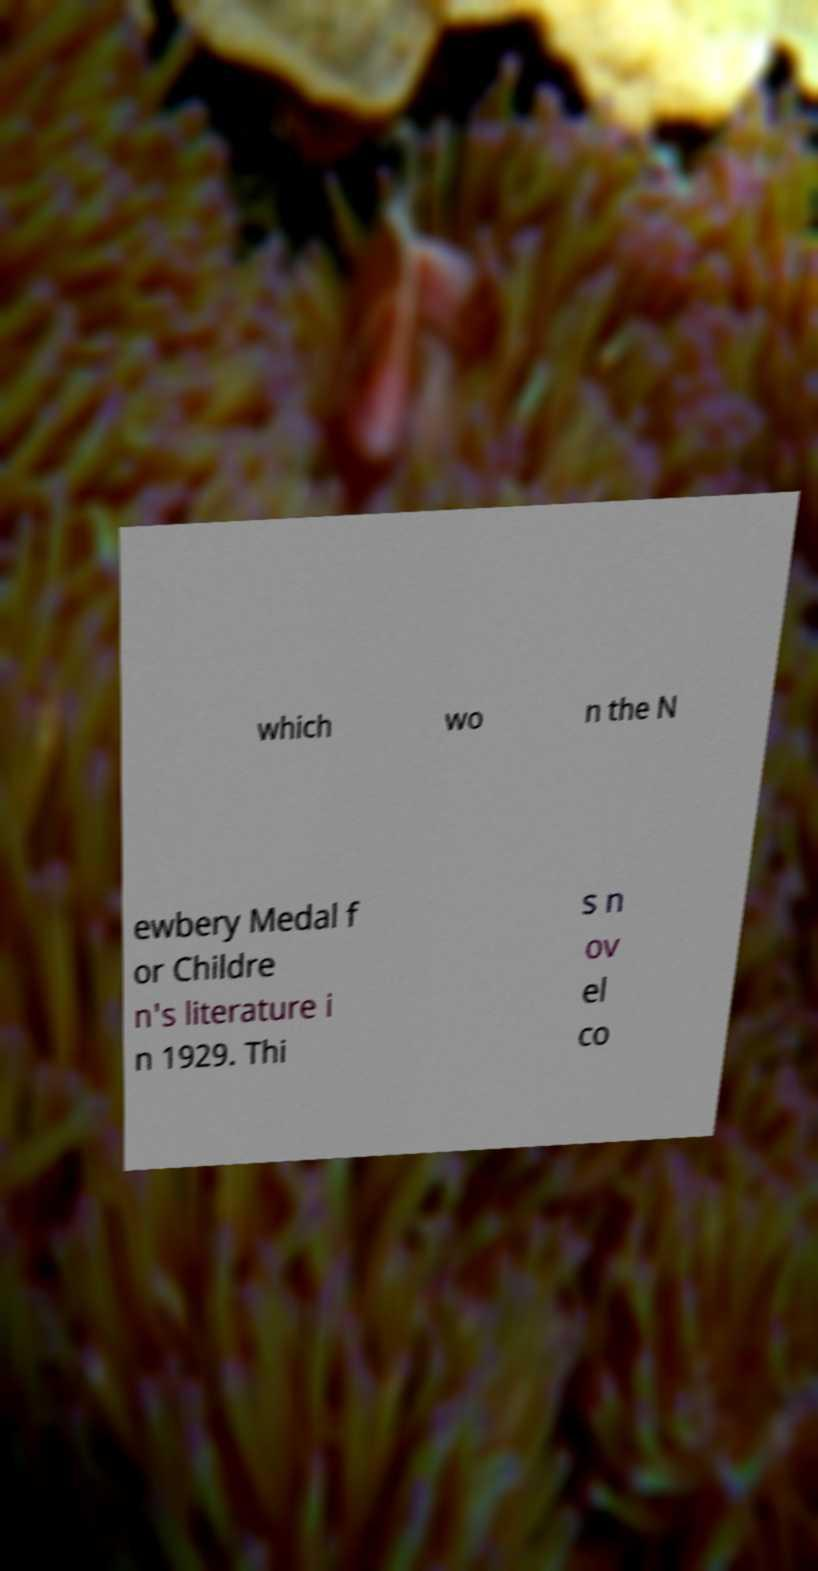I need the written content from this picture converted into text. Can you do that? which wo n the N ewbery Medal f or Childre n's literature i n 1929. Thi s n ov el co 